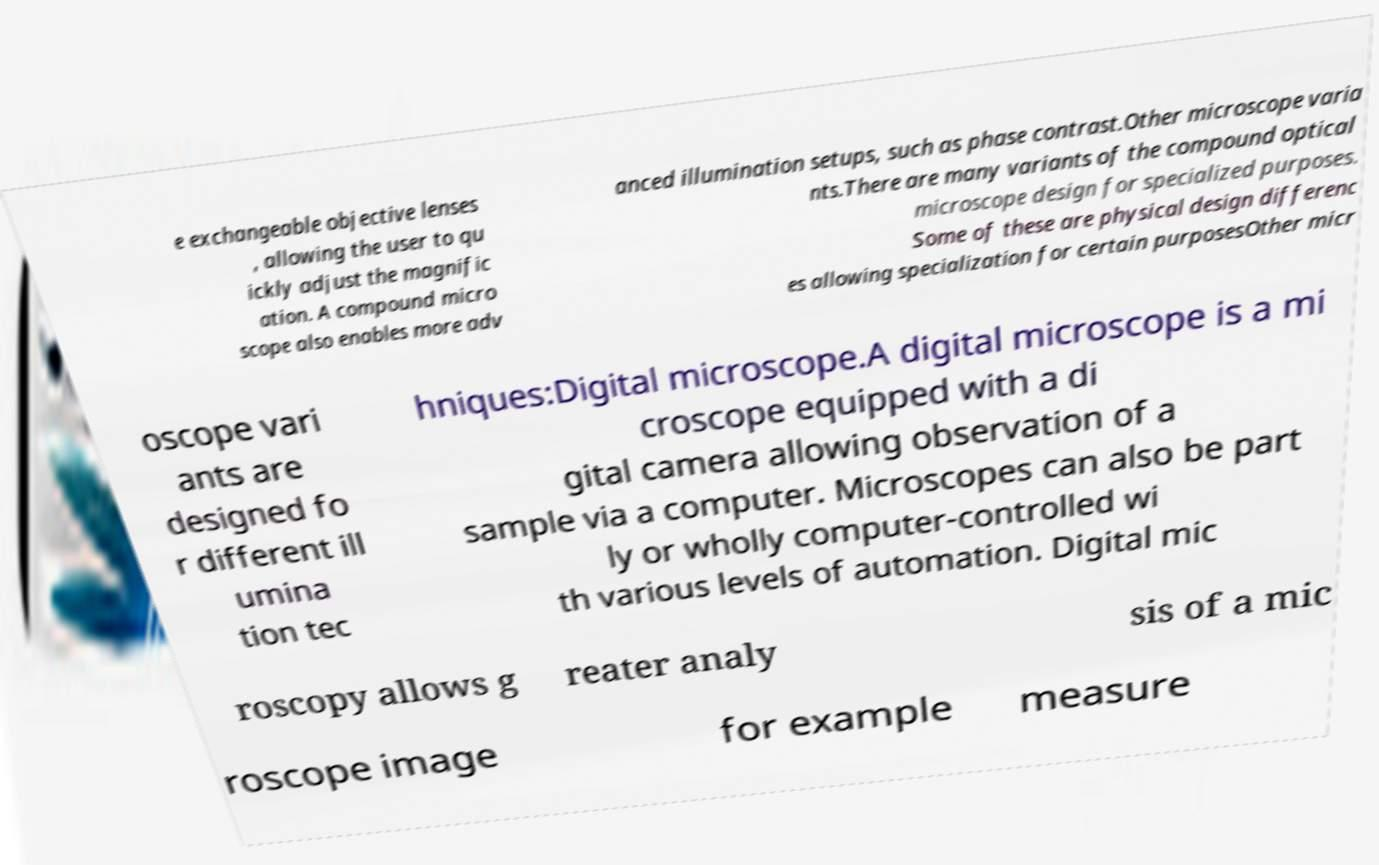There's text embedded in this image that I need extracted. Can you transcribe it verbatim? e exchangeable objective lenses , allowing the user to qu ickly adjust the magnific ation. A compound micro scope also enables more adv anced illumination setups, such as phase contrast.Other microscope varia nts.There are many variants of the compound optical microscope design for specialized purposes. Some of these are physical design differenc es allowing specialization for certain purposesOther micr oscope vari ants are designed fo r different ill umina tion tec hniques:Digital microscope.A digital microscope is a mi croscope equipped with a di gital camera allowing observation of a sample via a computer. Microscopes can also be part ly or wholly computer-controlled wi th various levels of automation. Digital mic roscopy allows g reater analy sis of a mic roscope image for example measure 